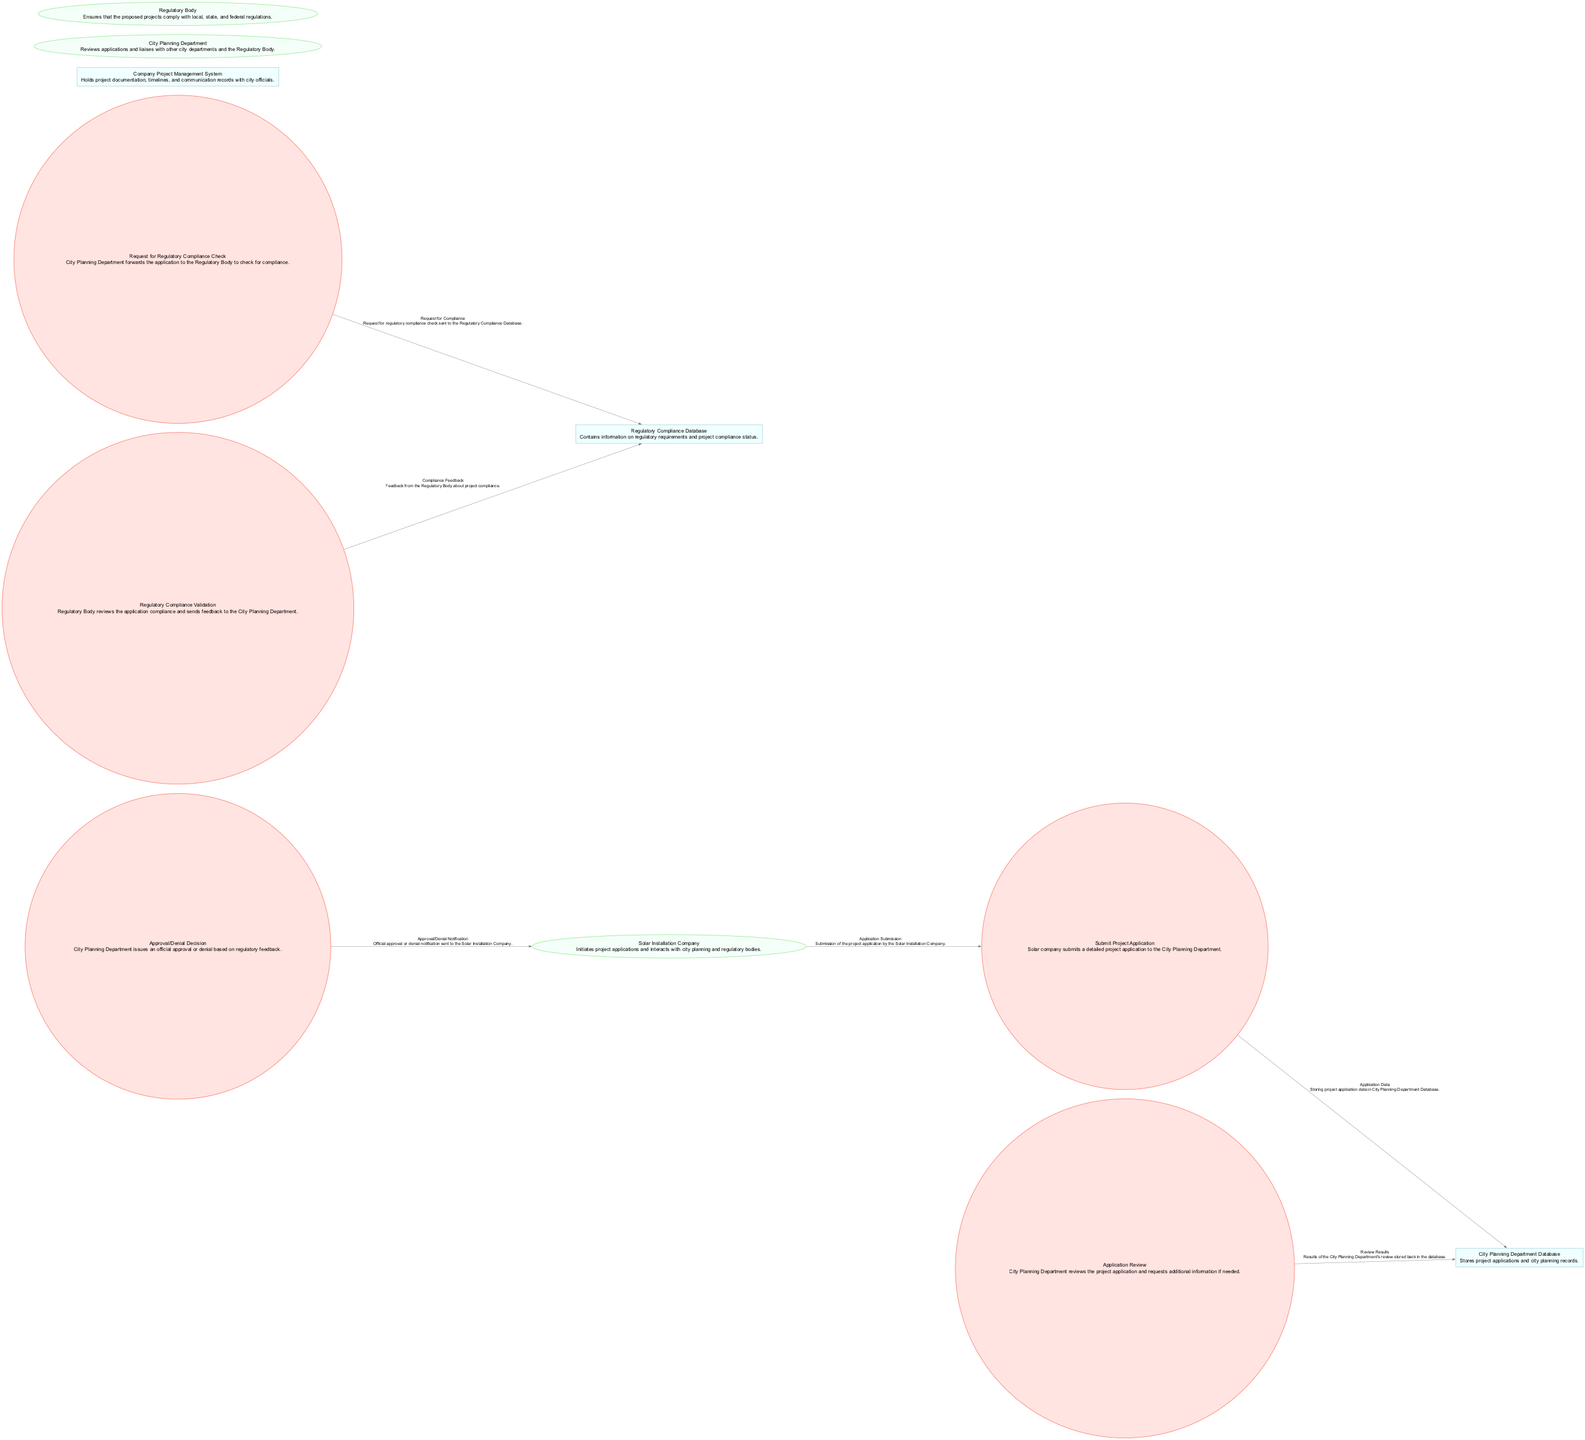What is the first process in the diagram? The first process is labeled as "P1", titled "Submit Project Application". It is the starting point of the data flow from the solar installation company to the City Planning Department.
Answer: Submit Project Application How many data stores are present in the diagram? There are three data stores: City Planning Department Database, Regulatory Compliance Database, and Company Project Management System. These are represented as nodes in the diagram where data is stored.
Answer: 3 What entity initiates the project application? The Solar Installation Company is the external entity that initiates the project application according to the first process, "Submit Project Application".
Answer: Solar Installation Company What feedback does the Regulatory Body provide? The Regulatory Body provides "Compliance Feedback" in response to the application compliance check performed as part of the process flow. This feedback is crucial for the next steps in the approval process.
Answer: Compliance Feedback Which process requests regulatory compliance checks? The process titled "Request for Regulatory Compliance Check" (P3) is specifically responsible for forwarding the application to the Regulatory Body to check for compliance.
Answer: Request for Regulatory Compliance Check What is the final output of the approval process? The final output of the approval process is the "Approval/Denial Notification" sent to the Solar Installation Company, indicating the decision made by the City Planning Department.
Answer: Approval/Denial Notification What does the City Planning Department database store? The City Planning Department Database stores project applications and city planning records as per its description provided in the diagram.
Answer: Project applications and city planning records What process validates regulatory compliance? The process labeled "Regulatory Compliance Validation" (P4) is responsible for reviewing the application for compliance and providing feedback to the City Planning Department.
Answer: Regulatory Compliance Validation Which external entity reviews the project application? The City Planning Department is the external entity that reviews the project application as indicated in the second process labeled "Application Review".
Answer: City Planning Department 